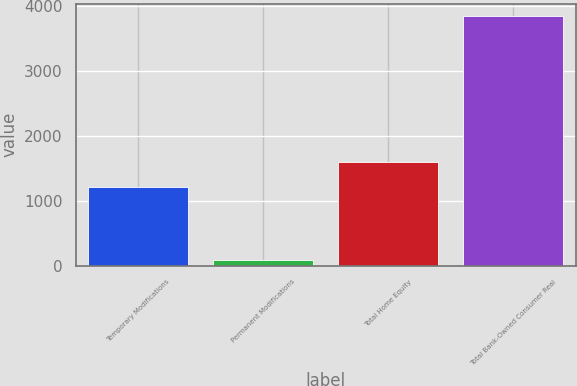Convert chart. <chart><loc_0><loc_0><loc_500><loc_500><bar_chart><fcel>Temporary Modifications<fcel>Permanent Modifications<fcel>Total Home Equity<fcel>Total Bank-Owned Consumer Real<nl><fcel>1215<fcel>92<fcel>1589.5<fcel>3837<nl></chart> 